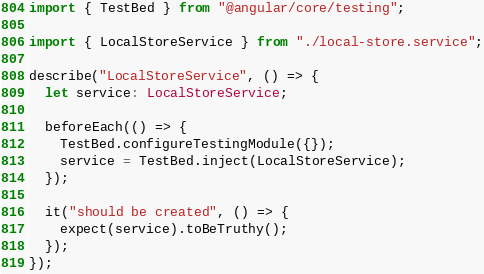<code> <loc_0><loc_0><loc_500><loc_500><_TypeScript_>import { TestBed } from "@angular/core/testing";

import { LocalStoreService } from "./local-store.service";

describe("LocalStoreService", () => {
  let service: LocalStoreService;

  beforeEach(() => {
    TestBed.configureTestingModule({});
    service = TestBed.inject(LocalStoreService);
  });

  it("should be created", () => {
    expect(service).toBeTruthy();
  });
});
</code> 